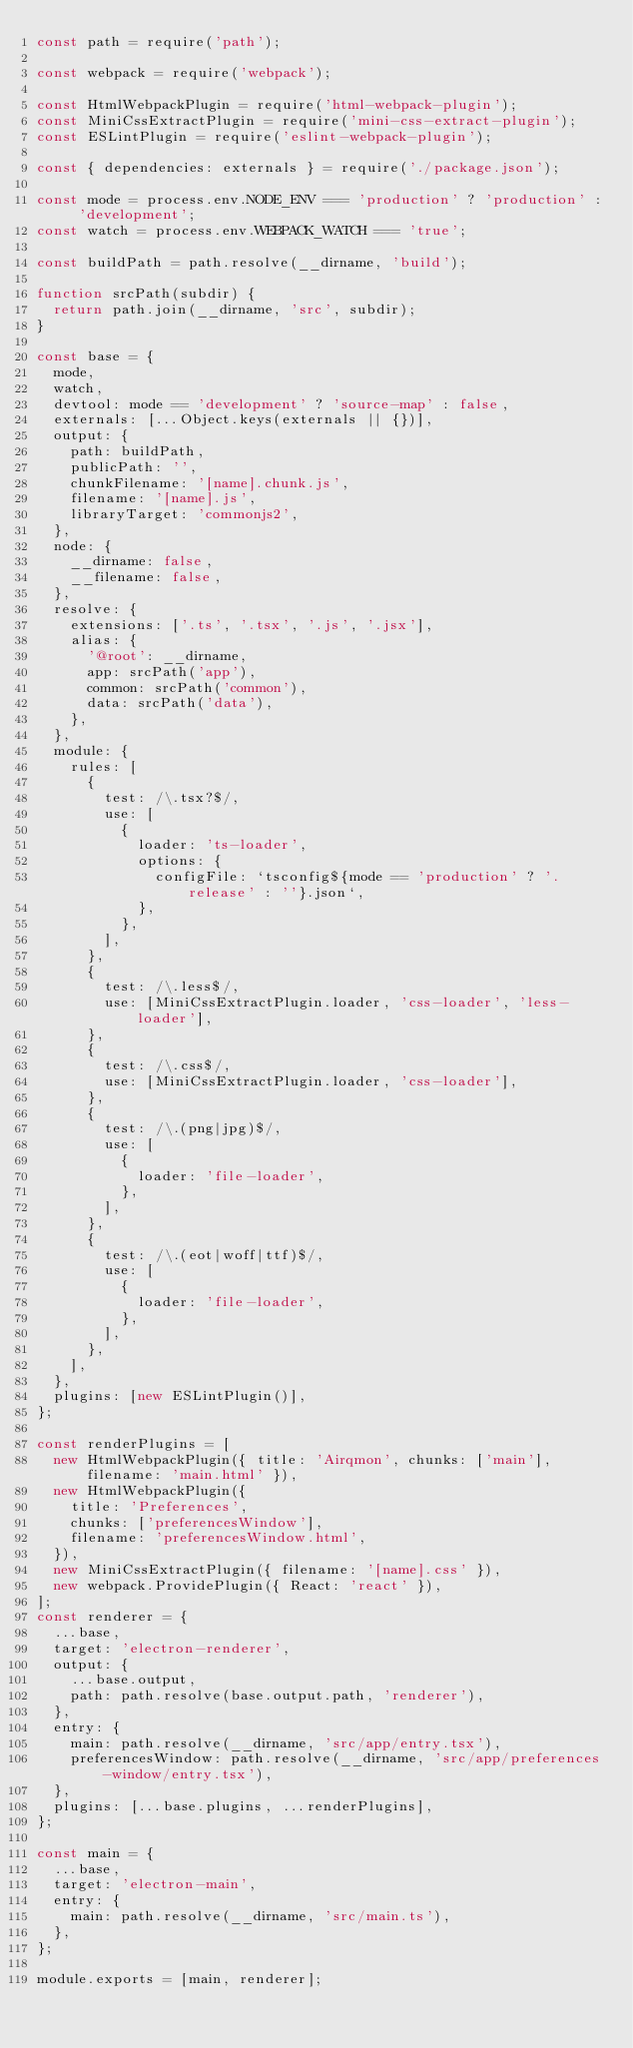<code> <loc_0><loc_0><loc_500><loc_500><_JavaScript_>const path = require('path');

const webpack = require('webpack');

const HtmlWebpackPlugin = require('html-webpack-plugin');
const MiniCssExtractPlugin = require('mini-css-extract-plugin');
const ESLintPlugin = require('eslint-webpack-plugin');

const { dependencies: externals } = require('./package.json');

const mode = process.env.NODE_ENV === 'production' ? 'production' : 'development';
const watch = process.env.WEBPACK_WATCH === 'true';

const buildPath = path.resolve(__dirname, 'build');

function srcPath(subdir) {
  return path.join(__dirname, 'src', subdir);
}

const base = {
  mode,
  watch,
  devtool: mode == 'development' ? 'source-map' : false,
  externals: [...Object.keys(externals || {})],
  output: {
    path: buildPath,
    publicPath: '',
    chunkFilename: '[name].chunk.js',
    filename: '[name].js',
    libraryTarget: 'commonjs2',
  },
  node: {
    __dirname: false,
    __filename: false,
  },
  resolve: {
    extensions: ['.ts', '.tsx', '.js', '.jsx'],
    alias: {
      '@root': __dirname,
      app: srcPath('app'),
      common: srcPath('common'),
      data: srcPath('data'),
    },
  },
  module: {
    rules: [
      {
        test: /\.tsx?$/,
        use: [
          {
            loader: 'ts-loader',
            options: {
              configFile: `tsconfig${mode == 'production' ? '.release' : ''}.json`,
            },
          },
        ],
      },
      {
        test: /\.less$/,
        use: [MiniCssExtractPlugin.loader, 'css-loader', 'less-loader'],
      },
      {
        test: /\.css$/,
        use: [MiniCssExtractPlugin.loader, 'css-loader'],
      },
      {
        test: /\.(png|jpg)$/,
        use: [
          {
            loader: 'file-loader',
          },
        ],
      },
      {
        test: /\.(eot|woff|ttf)$/,
        use: [
          {
            loader: 'file-loader',
          },
        ],
      },
    ],
  },
  plugins: [new ESLintPlugin()],
};

const renderPlugins = [
  new HtmlWebpackPlugin({ title: 'Airqmon', chunks: ['main'], filename: 'main.html' }),
  new HtmlWebpackPlugin({
    title: 'Preferences',
    chunks: ['preferencesWindow'],
    filename: 'preferencesWindow.html',
  }),
  new MiniCssExtractPlugin({ filename: '[name].css' }),
  new webpack.ProvidePlugin({ React: 'react' }),
];
const renderer = {
  ...base,
  target: 'electron-renderer',
  output: {
    ...base.output,
    path: path.resolve(base.output.path, 'renderer'),
  },
  entry: {
    main: path.resolve(__dirname, 'src/app/entry.tsx'),
    preferencesWindow: path.resolve(__dirname, 'src/app/preferences-window/entry.tsx'),
  },
  plugins: [...base.plugins, ...renderPlugins],
};

const main = {
  ...base,
  target: 'electron-main',
  entry: {
    main: path.resolve(__dirname, 'src/main.ts'),
  },
};

module.exports = [main, renderer];
</code> 